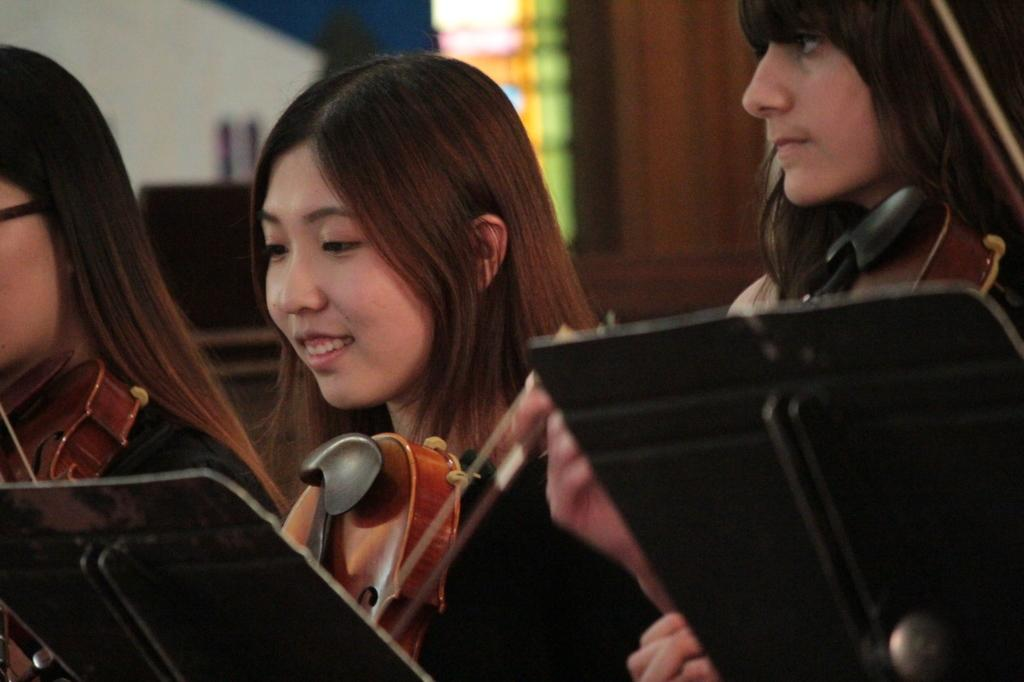How many people are in the image? There are three persons in the image. What are the three persons doing in the image? Each of the three persons is holding a musical instrument. What game are the three persons playing in the image? There is no game being played in the image; the three persons are holding musical instruments. What is the condition of the musical instruments in the image? The provided facts do not mention the condition of the musical instruments, so we cannot answer this question definitively. 